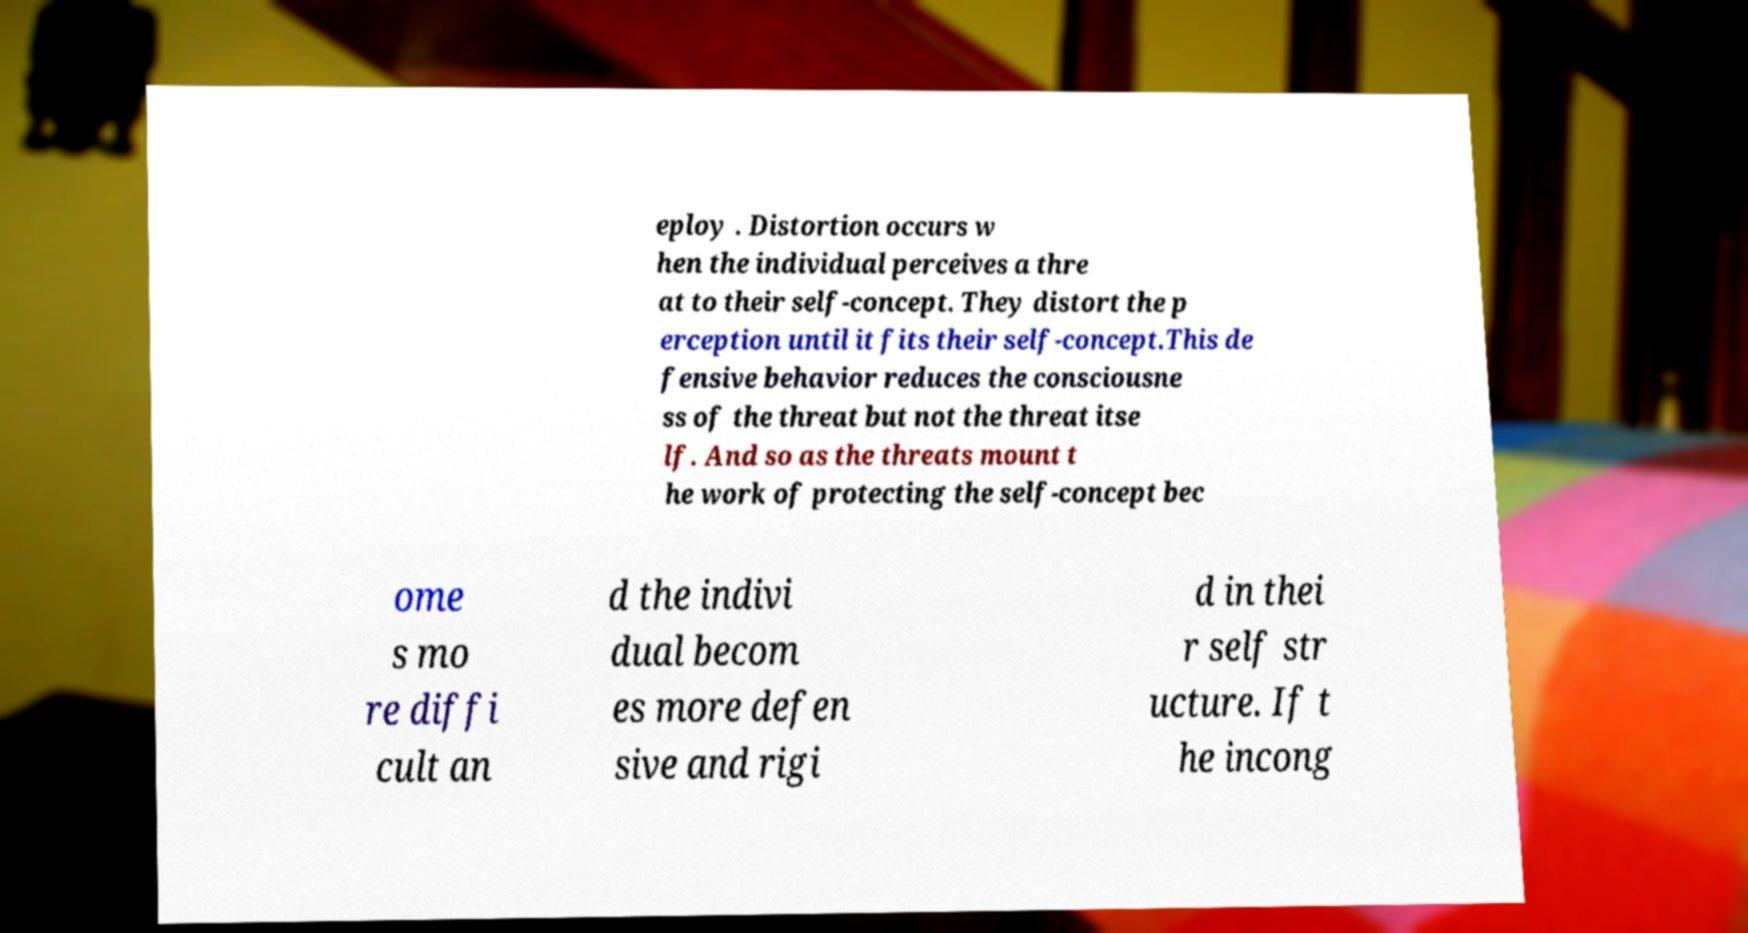Can you read and provide the text displayed in the image?This photo seems to have some interesting text. Can you extract and type it out for me? eploy . Distortion occurs w hen the individual perceives a thre at to their self-concept. They distort the p erception until it fits their self-concept.This de fensive behavior reduces the consciousne ss of the threat but not the threat itse lf. And so as the threats mount t he work of protecting the self-concept bec ome s mo re diffi cult an d the indivi dual becom es more defen sive and rigi d in thei r self str ucture. If t he incong 